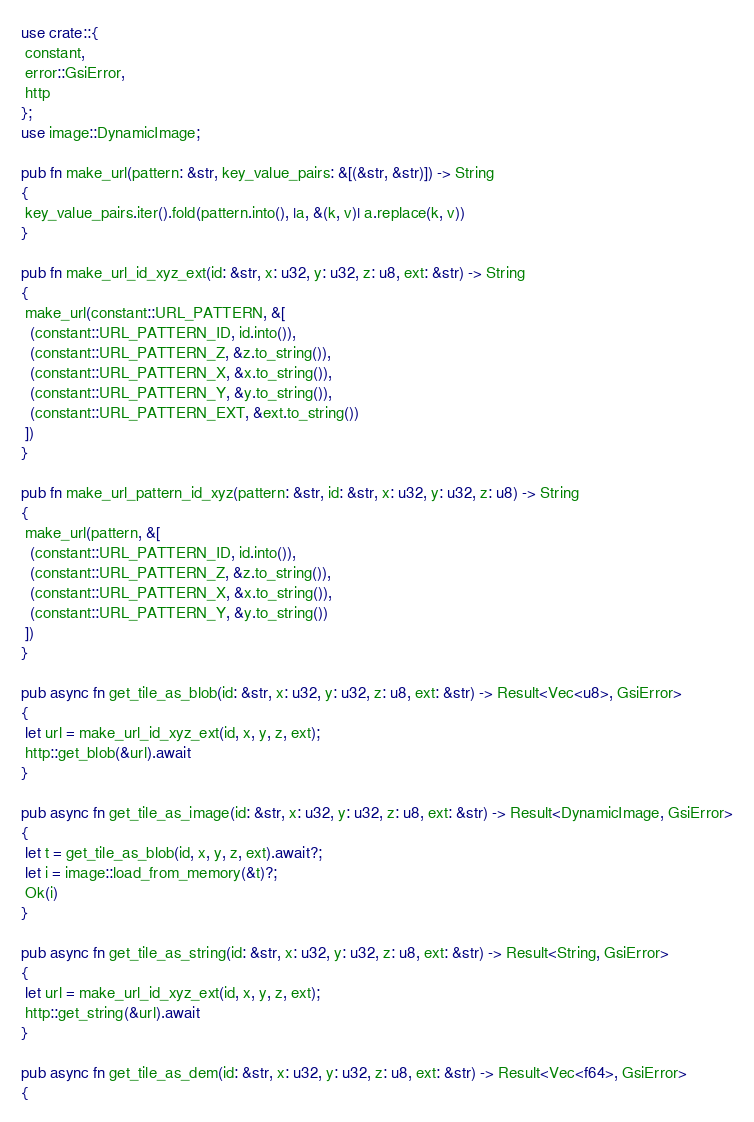<code> <loc_0><loc_0><loc_500><loc_500><_Rust_>use crate::{
 constant,
 error::GsiError,
 http
};
use image::DynamicImage;

pub fn make_url(pattern: &str, key_value_pairs: &[(&str, &str)]) -> String
{
 key_value_pairs.iter().fold(pattern.into(), |a, &(k, v)| a.replace(k, v))
}

pub fn make_url_id_xyz_ext(id: &str, x: u32, y: u32, z: u8, ext: &str) -> String
{
 make_url(constant::URL_PATTERN, &[
  (constant::URL_PATTERN_ID, id.into()),
  (constant::URL_PATTERN_Z, &z.to_string()),
  (constant::URL_PATTERN_X, &x.to_string()),
  (constant::URL_PATTERN_Y, &y.to_string()),
  (constant::URL_PATTERN_EXT, &ext.to_string())
 ])
}

pub fn make_url_pattern_id_xyz(pattern: &str, id: &str, x: u32, y: u32, z: u8) -> String
{
 make_url(pattern, &[
  (constant::URL_PATTERN_ID, id.into()),
  (constant::URL_PATTERN_Z, &z.to_string()),
  (constant::URL_PATTERN_X, &x.to_string()),
  (constant::URL_PATTERN_Y, &y.to_string())
 ])
}

pub async fn get_tile_as_blob(id: &str, x: u32, y: u32, z: u8, ext: &str) -> Result<Vec<u8>, GsiError>
{
 let url = make_url_id_xyz_ext(id, x, y, z, ext);
 http::get_blob(&url).await
}

pub async fn get_tile_as_image(id: &str, x: u32, y: u32, z: u8, ext: &str) -> Result<DynamicImage, GsiError>
{
 let t = get_tile_as_blob(id, x, y, z, ext).await?;
 let i = image::load_from_memory(&t)?;
 Ok(i)
}

pub async fn get_tile_as_string(id: &str, x: u32, y: u32, z: u8, ext: &str) -> Result<String, GsiError>
{
 let url = make_url_id_xyz_ext(id, x, y, z, ext);
 http::get_string(&url).await
}

pub async fn get_tile_as_dem(id: &str, x: u32, y: u32, z: u8, ext: &str) -> Result<Vec<f64>, GsiError>
{</code> 